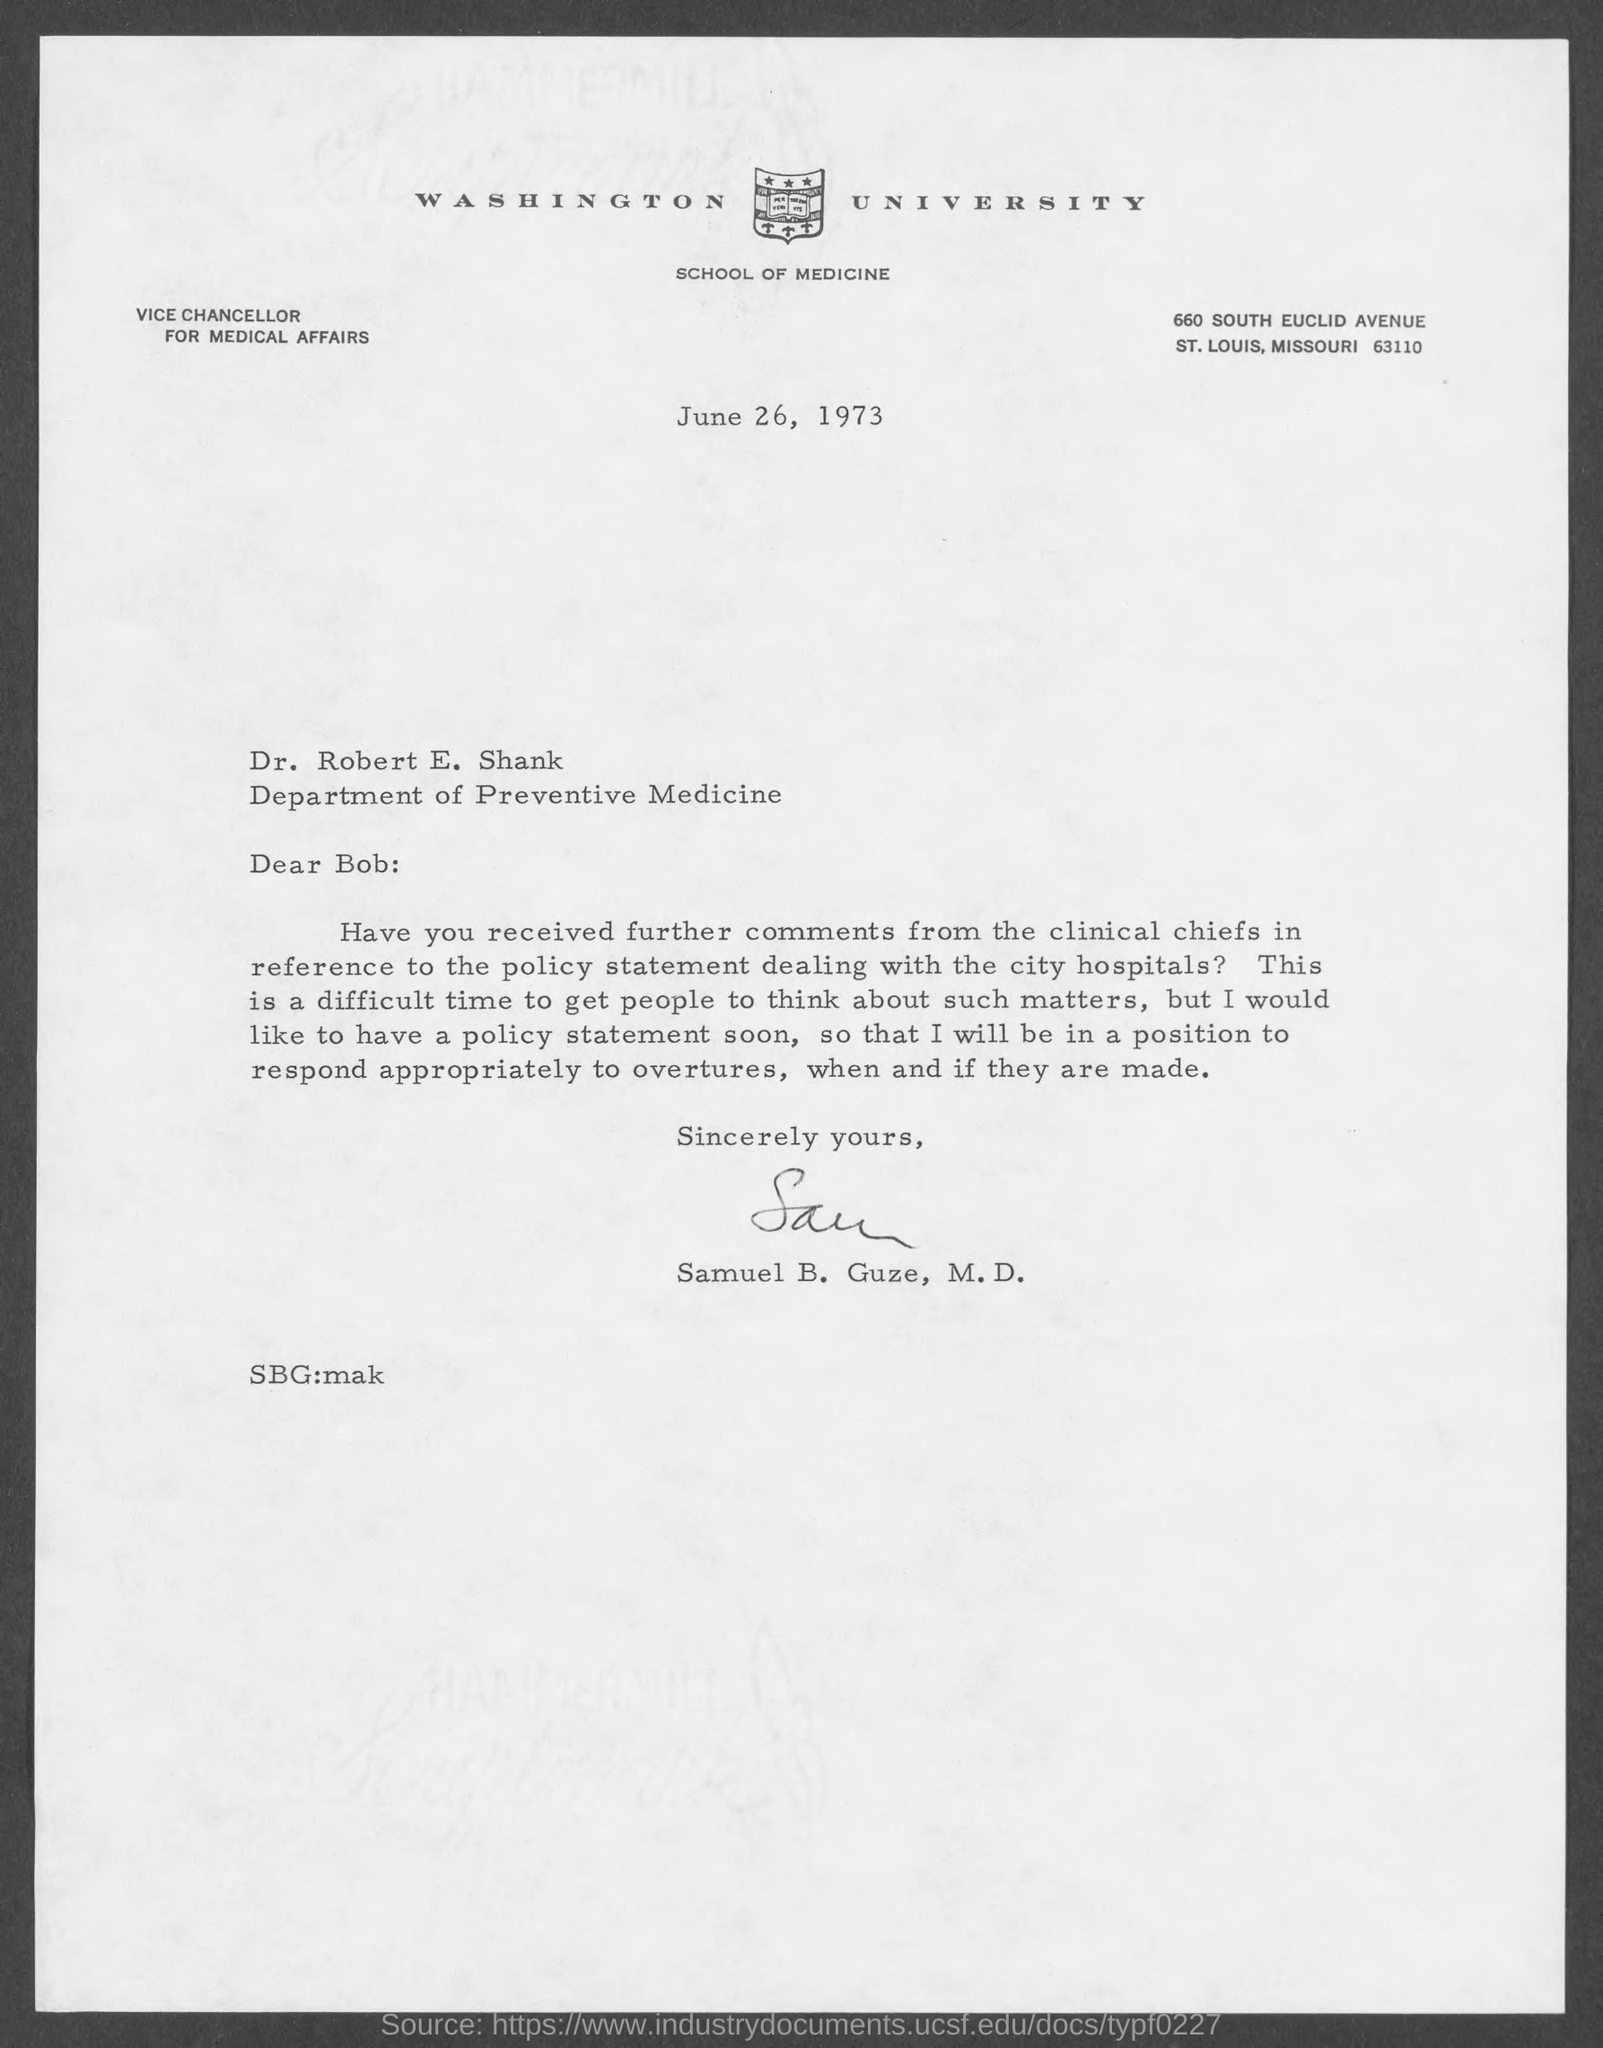Which University is mentioned in the letter head?
Provide a short and direct response. Washington University. What is the date mentioned in this letter?
Offer a very short reply. June 26, 1973. 